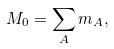Convert formula to latex. <formula><loc_0><loc_0><loc_500><loc_500>M _ { 0 } = \sum _ { A } m _ { A } ,</formula> 